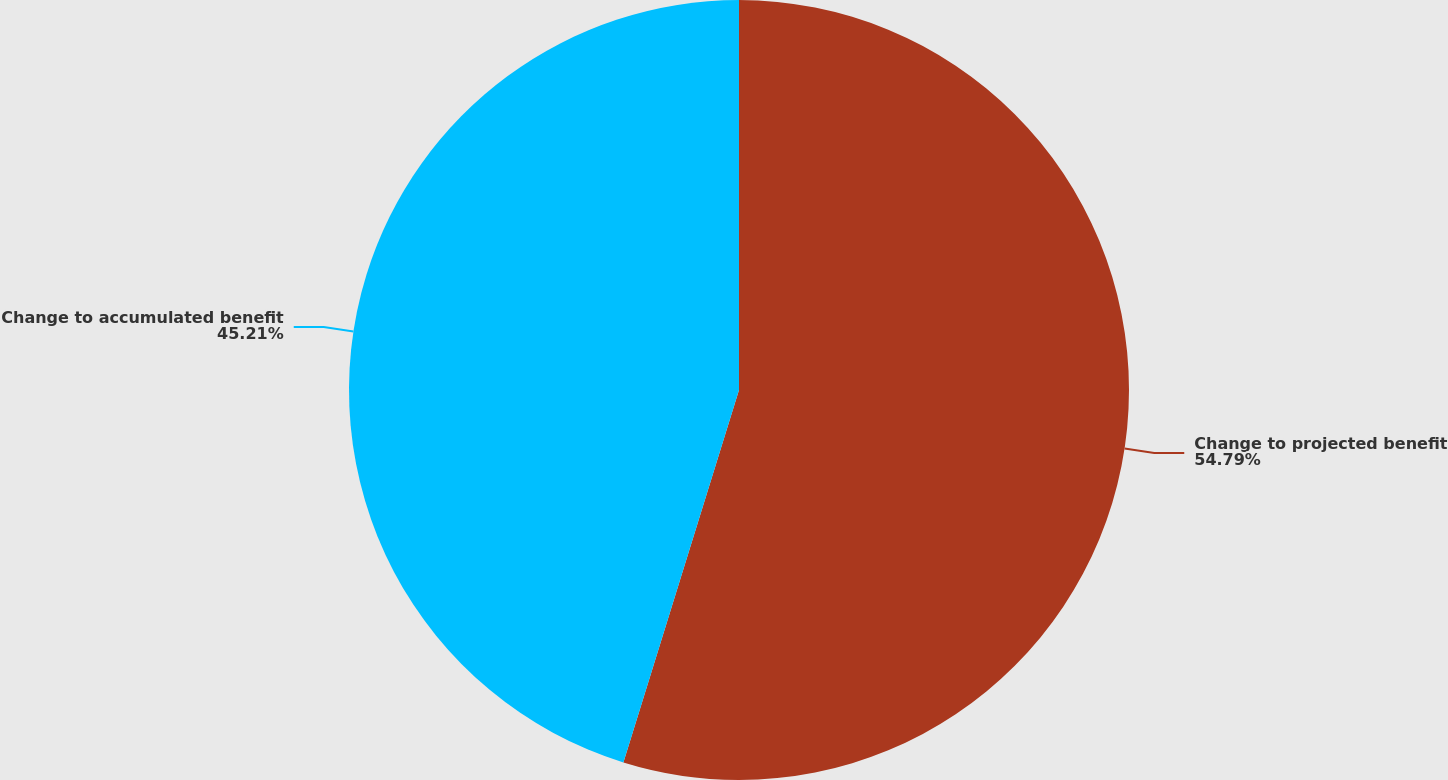Convert chart. <chart><loc_0><loc_0><loc_500><loc_500><pie_chart><fcel>Change to projected benefit<fcel>Change to accumulated benefit<nl><fcel>54.79%<fcel>45.21%<nl></chart> 